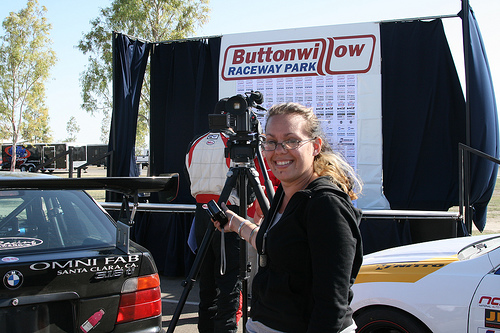<image>
Can you confirm if the camera is to the right of the man? No. The camera is not to the right of the man. The horizontal positioning shows a different relationship. 